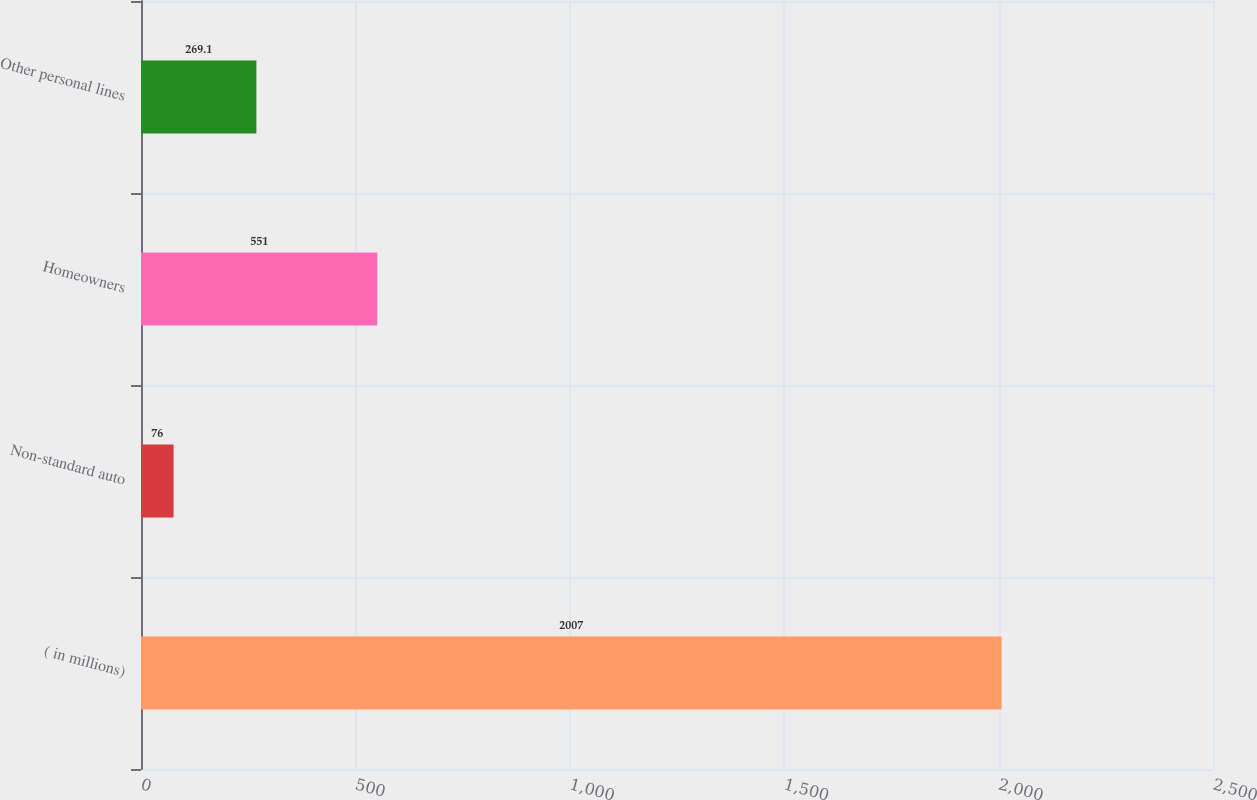Convert chart to OTSL. <chart><loc_0><loc_0><loc_500><loc_500><bar_chart><fcel>( in millions)<fcel>Non-standard auto<fcel>Homeowners<fcel>Other personal lines<nl><fcel>2007<fcel>76<fcel>551<fcel>269.1<nl></chart> 